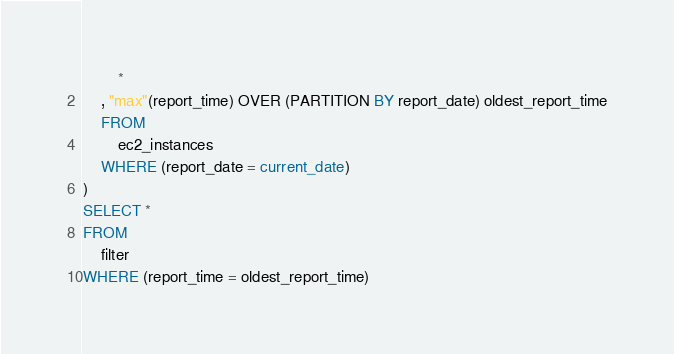Convert code to text. <code><loc_0><loc_0><loc_500><loc_500><_SQL_>		*
	, "max"(report_time) OVER (PARTITION BY report_date) oldest_report_time
	FROM
		ec2_instances
	WHERE (report_date = current_date)
) 
SELECT *
FROM
	filter
WHERE (report_time = oldest_report_time)</code> 